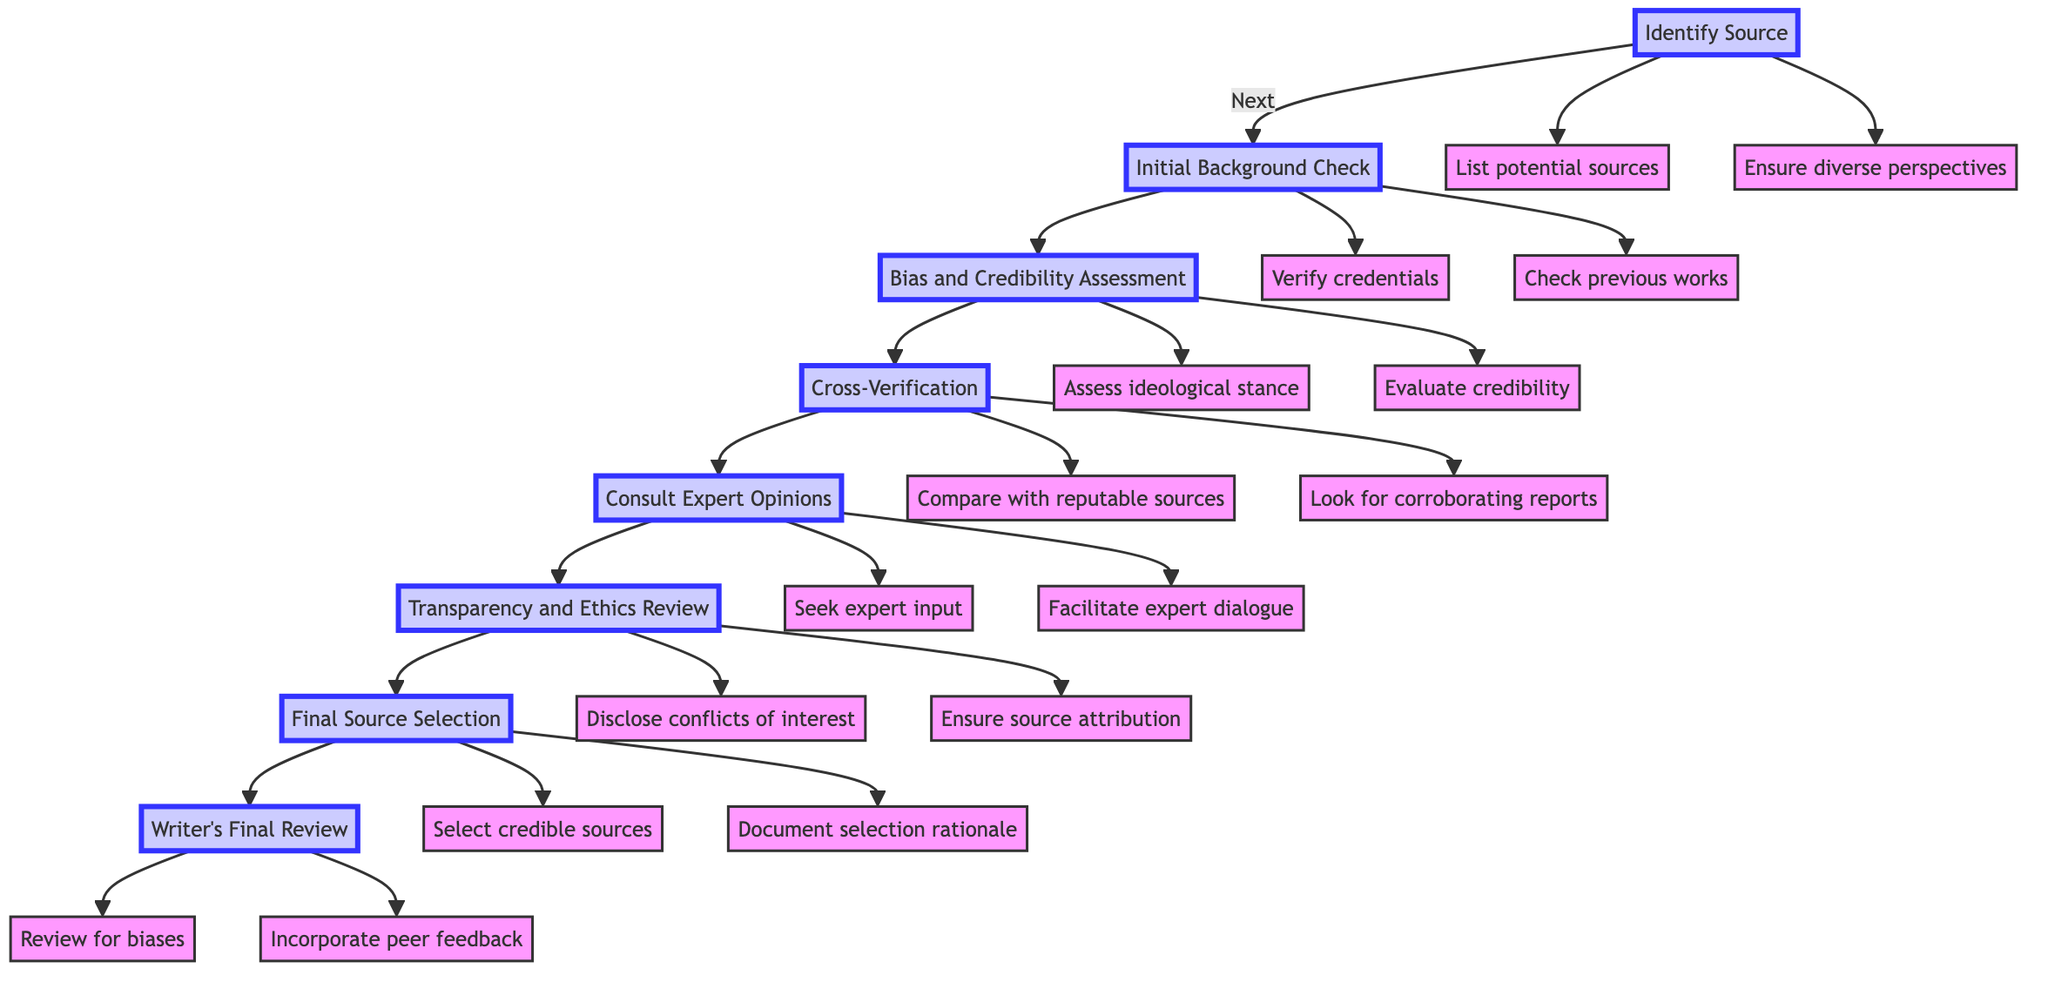What's the first stage in the protocol? The diagram shows that the first stage is "Identify Source." This can be determined as it is the starting point of the flow chart, depicted at the top of the diagram.
Answer: Identify Source How many actions are there in the "Cross-Verification" stage? The "Cross-Verification" stage lists two actions: "Compare information with at least three other reputable sources" and "Look for corroborating reports." Hence, counting these listed actions gives a total of two.
Answer: 2 What action is associated with the "Transparency and Ethics Review" stage? The actions for the "Transparency and Ethics Review" stage are "Disclose potential conflicts of interest" and "Ensure transparency in source attribution." These actions can be identified as they are directly linked to this specific stage in the flow chart.
Answer: Disclose potential conflicts of interest and Ensure transparency in source attribution What comes after the "Consult Expert Opinions" stage? Following the "Consult Expert Opinions" stage, the next step illustrated in the diagram is "Transparency and Ethics Review." This sequence is indicated by the directed arrow in the flow from one stage to the next.
Answer: Transparency and Ethics Review Which stage involves seeking input from subject matter experts? The "Consult Expert Opinions" stage involves seeking input from subject matter experts. This can be inferred from the specific actions detailed under this stage that include consulting experts and facilitating dialogue.
Answer: Consult Expert Opinions What is the final stage of the vetting protocol? According to the diagram, the final stage of the vetting protocol is "Writer's Final Review." This stage is clearly positioned at the end of the flow chart sequence.
Answer: Writer's Final Review How many total stages are there in the protocol? The diagram outlines a total of eight distinct stages: Identify Source, Initial Background Check, Bias and Credibility Assessment, Cross-Verification, Consult Expert Opinions, Transparency and Ethics Review, Final Source Selection, and Writer's Final Review. A count of these stages confirms the total is eight.
Answer: 8 What must be ensured in the "Final Source Selection" stage? In the "Final Source Selection" stage, it is crucial to "Select sources with the highest credibility and balanced viewpoints" and "Document the rationale for source selection." These requirements indicate what actions need to be taken during this stage.
Answer: Select sources with the highest credibility and balanced viewpoints and Document the rationale for source selection 